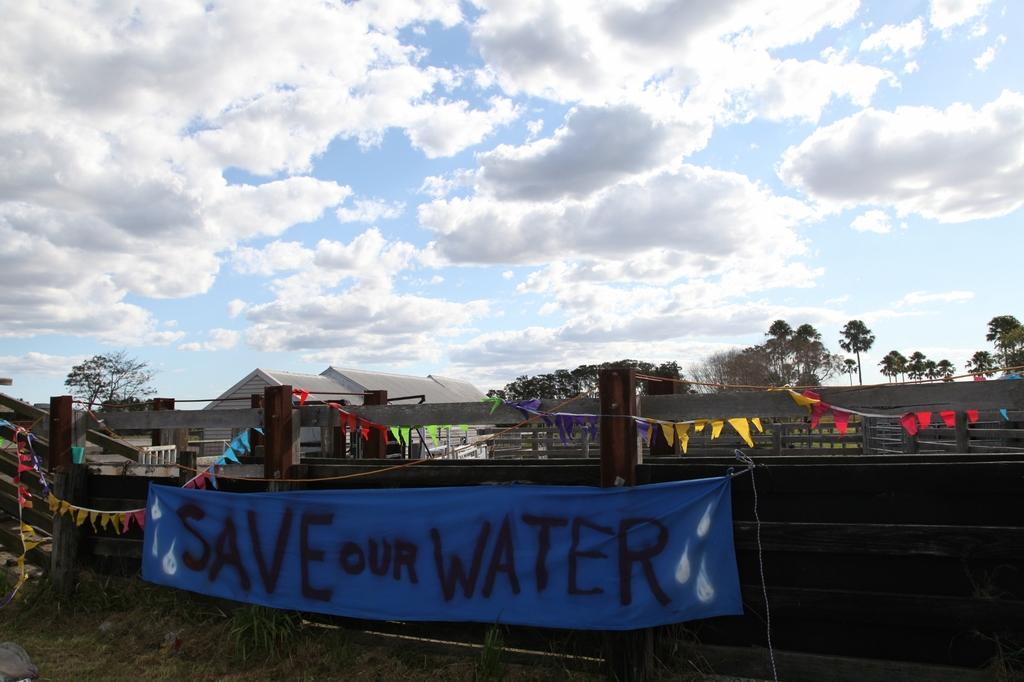Could you give a brief overview of what you see in this image? In this image there are few trees, fences, decorative papers attached to a rope, a cloth with some text, a house and some clouds in the sky. 